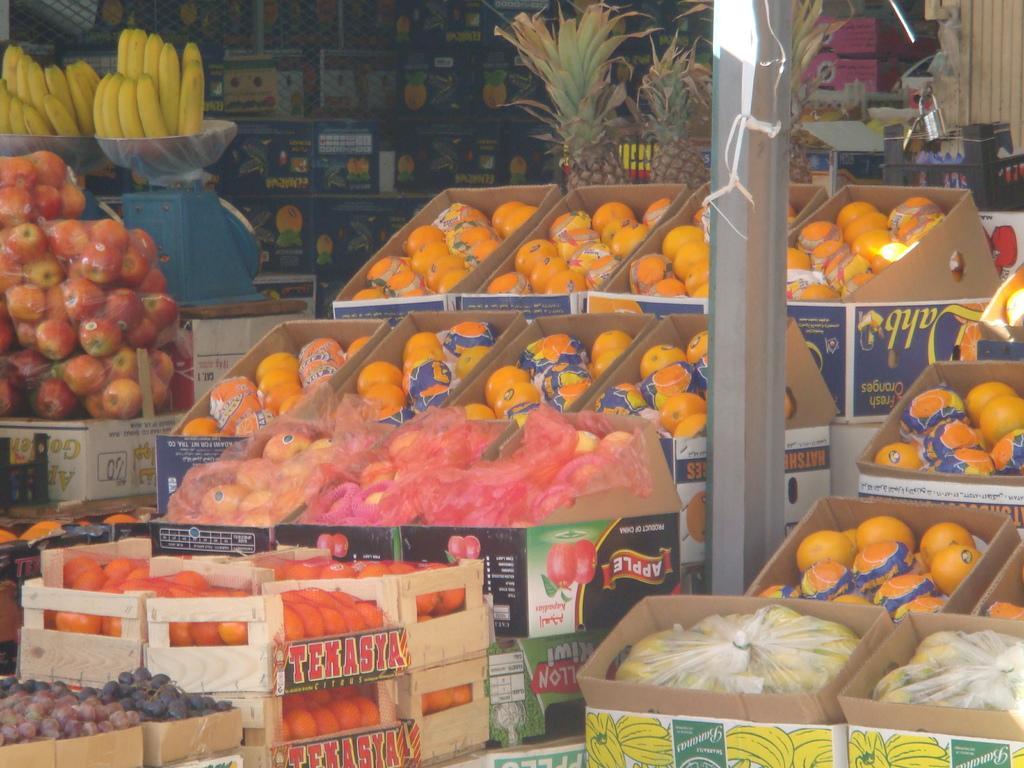Can you describe this image briefly? In the image we can see some fruits. In the middle of the image there is a pole. 